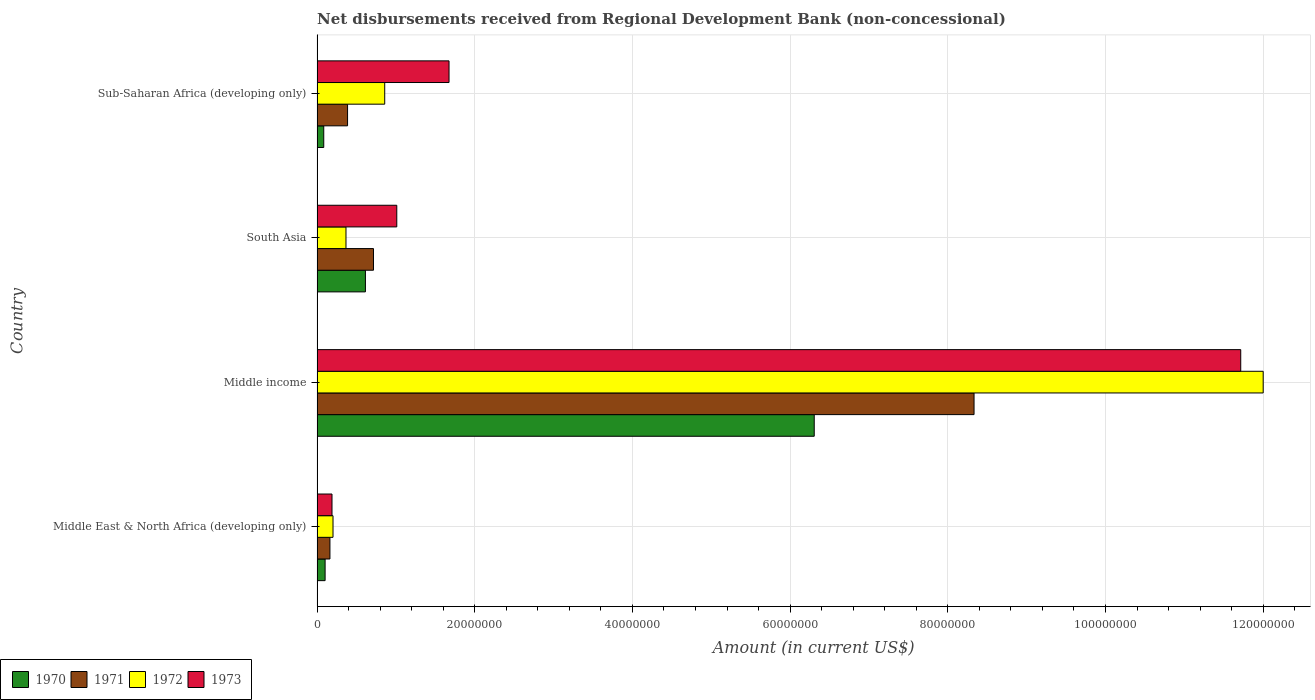How many different coloured bars are there?
Your answer should be very brief. 4. How many groups of bars are there?
Your response must be concise. 4. Are the number of bars on each tick of the Y-axis equal?
Give a very brief answer. Yes. How many bars are there on the 1st tick from the top?
Offer a very short reply. 4. In how many cases, is the number of bars for a given country not equal to the number of legend labels?
Provide a short and direct response. 0. What is the amount of disbursements received from Regional Development Bank in 1973 in Middle East & North Africa (developing only)?
Offer a very short reply. 1.90e+06. Across all countries, what is the maximum amount of disbursements received from Regional Development Bank in 1971?
Provide a succinct answer. 8.33e+07. Across all countries, what is the minimum amount of disbursements received from Regional Development Bank in 1972?
Your answer should be very brief. 2.02e+06. In which country was the amount of disbursements received from Regional Development Bank in 1970 maximum?
Provide a succinct answer. Middle income. In which country was the amount of disbursements received from Regional Development Bank in 1972 minimum?
Your response must be concise. Middle East & North Africa (developing only). What is the total amount of disbursements received from Regional Development Bank in 1972 in the graph?
Make the answer very short. 1.34e+08. What is the difference between the amount of disbursements received from Regional Development Bank in 1973 in Middle East & North Africa (developing only) and that in Sub-Saharan Africa (developing only)?
Keep it short and to the point. -1.48e+07. What is the difference between the amount of disbursements received from Regional Development Bank in 1972 in Sub-Saharan Africa (developing only) and the amount of disbursements received from Regional Development Bank in 1973 in Middle income?
Provide a short and direct response. -1.09e+08. What is the average amount of disbursements received from Regional Development Bank in 1973 per country?
Make the answer very short. 3.65e+07. What is the difference between the amount of disbursements received from Regional Development Bank in 1971 and amount of disbursements received from Regional Development Bank in 1972 in Middle East & North Africa (developing only)?
Your response must be concise. -3.89e+05. What is the ratio of the amount of disbursements received from Regional Development Bank in 1972 in Middle East & North Africa (developing only) to that in Sub-Saharan Africa (developing only)?
Provide a succinct answer. 0.24. What is the difference between the highest and the second highest amount of disbursements received from Regional Development Bank in 1972?
Give a very brief answer. 1.11e+08. What is the difference between the highest and the lowest amount of disbursements received from Regional Development Bank in 1970?
Your answer should be very brief. 6.22e+07. In how many countries, is the amount of disbursements received from Regional Development Bank in 1973 greater than the average amount of disbursements received from Regional Development Bank in 1973 taken over all countries?
Give a very brief answer. 1. Is it the case that in every country, the sum of the amount of disbursements received from Regional Development Bank in 1972 and amount of disbursements received from Regional Development Bank in 1970 is greater than the sum of amount of disbursements received from Regional Development Bank in 1971 and amount of disbursements received from Regional Development Bank in 1973?
Offer a terse response. No. What does the 4th bar from the top in Middle East & North Africa (developing only) represents?
Give a very brief answer. 1970. What does the 1st bar from the bottom in Sub-Saharan Africa (developing only) represents?
Provide a short and direct response. 1970. How many bars are there?
Offer a very short reply. 16. Are all the bars in the graph horizontal?
Your answer should be very brief. Yes. How many countries are there in the graph?
Your answer should be compact. 4. Are the values on the major ticks of X-axis written in scientific E-notation?
Offer a terse response. No. Does the graph contain any zero values?
Provide a succinct answer. No. Does the graph contain grids?
Your answer should be compact. Yes. Where does the legend appear in the graph?
Make the answer very short. Bottom left. How many legend labels are there?
Offer a very short reply. 4. How are the legend labels stacked?
Make the answer very short. Horizontal. What is the title of the graph?
Provide a succinct answer. Net disbursements received from Regional Development Bank (non-concessional). Does "1985" appear as one of the legend labels in the graph?
Make the answer very short. No. What is the label or title of the X-axis?
Provide a succinct answer. Amount (in current US$). What is the Amount (in current US$) in 1970 in Middle East & North Africa (developing only)?
Give a very brief answer. 1.02e+06. What is the Amount (in current US$) in 1971 in Middle East & North Africa (developing only)?
Your answer should be very brief. 1.64e+06. What is the Amount (in current US$) of 1972 in Middle East & North Africa (developing only)?
Your answer should be very brief. 2.02e+06. What is the Amount (in current US$) of 1973 in Middle East & North Africa (developing only)?
Provide a short and direct response. 1.90e+06. What is the Amount (in current US$) of 1970 in Middle income?
Your answer should be compact. 6.31e+07. What is the Amount (in current US$) in 1971 in Middle income?
Keep it short and to the point. 8.33e+07. What is the Amount (in current US$) of 1972 in Middle income?
Offer a terse response. 1.20e+08. What is the Amount (in current US$) of 1973 in Middle income?
Your answer should be very brief. 1.17e+08. What is the Amount (in current US$) in 1970 in South Asia?
Your answer should be very brief. 6.13e+06. What is the Amount (in current US$) in 1971 in South Asia?
Your answer should be very brief. 7.16e+06. What is the Amount (in current US$) in 1972 in South Asia?
Your answer should be very brief. 3.67e+06. What is the Amount (in current US$) of 1973 in South Asia?
Ensure brevity in your answer.  1.01e+07. What is the Amount (in current US$) in 1970 in Sub-Saharan Africa (developing only)?
Offer a very short reply. 8.50e+05. What is the Amount (in current US$) of 1971 in Sub-Saharan Africa (developing only)?
Your answer should be very brief. 3.87e+06. What is the Amount (in current US$) in 1972 in Sub-Saharan Africa (developing only)?
Ensure brevity in your answer.  8.58e+06. What is the Amount (in current US$) in 1973 in Sub-Saharan Africa (developing only)?
Offer a very short reply. 1.67e+07. Across all countries, what is the maximum Amount (in current US$) of 1970?
Provide a short and direct response. 6.31e+07. Across all countries, what is the maximum Amount (in current US$) in 1971?
Provide a succinct answer. 8.33e+07. Across all countries, what is the maximum Amount (in current US$) of 1972?
Ensure brevity in your answer.  1.20e+08. Across all countries, what is the maximum Amount (in current US$) of 1973?
Ensure brevity in your answer.  1.17e+08. Across all countries, what is the minimum Amount (in current US$) of 1970?
Your answer should be very brief. 8.50e+05. Across all countries, what is the minimum Amount (in current US$) of 1971?
Make the answer very short. 1.64e+06. Across all countries, what is the minimum Amount (in current US$) of 1972?
Offer a terse response. 2.02e+06. Across all countries, what is the minimum Amount (in current US$) in 1973?
Keep it short and to the point. 1.90e+06. What is the total Amount (in current US$) of 1970 in the graph?
Offer a terse response. 7.11e+07. What is the total Amount (in current US$) of 1971 in the graph?
Offer a very short reply. 9.60e+07. What is the total Amount (in current US$) in 1972 in the graph?
Offer a very short reply. 1.34e+08. What is the total Amount (in current US$) in 1973 in the graph?
Provide a succinct answer. 1.46e+08. What is the difference between the Amount (in current US$) of 1970 in Middle East & North Africa (developing only) and that in Middle income?
Your answer should be compact. -6.20e+07. What is the difference between the Amount (in current US$) in 1971 in Middle East & North Africa (developing only) and that in Middle income?
Keep it short and to the point. -8.17e+07. What is the difference between the Amount (in current US$) of 1972 in Middle East & North Africa (developing only) and that in Middle income?
Offer a very short reply. -1.18e+08. What is the difference between the Amount (in current US$) in 1973 in Middle East & North Africa (developing only) and that in Middle income?
Your response must be concise. -1.15e+08. What is the difference between the Amount (in current US$) of 1970 in Middle East & North Africa (developing only) and that in South Asia?
Your response must be concise. -5.11e+06. What is the difference between the Amount (in current US$) in 1971 in Middle East & North Africa (developing only) and that in South Asia?
Your answer should be very brief. -5.52e+06. What is the difference between the Amount (in current US$) of 1972 in Middle East & North Africa (developing only) and that in South Asia?
Ensure brevity in your answer.  -1.64e+06. What is the difference between the Amount (in current US$) of 1973 in Middle East & North Africa (developing only) and that in South Asia?
Offer a terse response. -8.22e+06. What is the difference between the Amount (in current US$) in 1970 in Middle East & North Africa (developing only) and that in Sub-Saharan Africa (developing only)?
Ensure brevity in your answer.  1.71e+05. What is the difference between the Amount (in current US$) in 1971 in Middle East & North Africa (developing only) and that in Sub-Saharan Africa (developing only)?
Ensure brevity in your answer.  -2.23e+06. What is the difference between the Amount (in current US$) of 1972 in Middle East & North Africa (developing only) and that in Sub-Saharan Africa (developing only)?
Keep it short and to the point. -6.56e+06. What is the difference between the Amount (in current US$) in 1973 in Middle East & North Africa (developing only) and that in Sub-Saharan Africa (developing only)?
Offer a terse response. -1.48e+07. What is the difference between the Amount (in current US$) in 1970 in Middle income and that in South Asia?
Provide a succinct answer. 5.69e+07. What is the difference between the Amount (in current US$) of 1971 in Middle income and that in South Asia?
Your answer should be compact. 7.62e+07. What is the difference between the Amount (in current US$) of 1972 in Middle income and that in South Asia?
Provide a succinct answer. 1.16e+08. What is the difference between the Amount (in current US$) of 1973 in Middle income and that in South Asia?
Your response must be concise. 1.07e+08. What is the difference between the Amount (in current US$) in 1970 in Middle income and that in Sub-Saharan Africa (developing only)?
Offer a very short reply. 6.22e+07. What is the difference between the Amount (in current US$) in 1971 in Middle income and that in Sub-Saharan Africa (developing only)?
Keep it short and to the point. 7.95e+07. What is the difference between the Amount (in current US$) of 1972 in Middle income and that in Sub-Saharan Africa (developing only)?
Offer a terse response. 1.11e+08. What is the difference between the Amount (in current US$) in 1973 in Middle income and that in Sub-Saharan Africa (developing only)?
Ensure brevity in your answer.  1.00e+08. What is the difference between the Amount (in current US$) of 1970 in South Asia and that in Sub-Saharan Africa (developing only)?
Keep it short and to the point. 5.28e+06. What is the difference between the Amount (in current US$) of 1971 in South Asia and that in Sub-Saharan Africa (developing only)?
Provide a short and direct response. 3.29e+06. What is the difference between the Amount (in current US$) of 1972 in South Asia and that in Sub-Saharan Africa (developing only)?
Your response must be concise. -4.91e+06. What is the difference between the Amount (in current US$) of 1973 in South Asia and that in Sub-Saharan Africa (developing only)?
Offer a terse response. -6.63e+06. What is the difference between the Amount (in current US$) of 1970 in Middle East & North Africa (developing only) and the Amount (in current US$) of 1971 in Middle income?
Your answer should be compact. -8.23e+07. What is the difference between the Amount (in current US$) in 1970 in Middle East & North Africa (developing only) and the Amount (in current US$) in 1972 in Middle income?
Keep it short and to the point. -1.19e+08. What is the difference between the Amount (in current US$) of 1970 in Middle East & North Africa (developing only) and the Amount (in current US$) of 1973 in Middle income?
Provide a short and direct response. -1.16e+08. What is the difference between the Amount (in current US$) of 1971 in Middle East & North Africa (developing only) and the Amount (in current US$) of 1972 in Middle income?
Give a very brief answer. -1.18e+08. What is the difference between the Amount (in current US$) in 1971 in Middle East & North Africa (developing only) and the Amount (in current US$) in 1973 in Middle income?
Give a very brief answer. -1.16e+08. What is the difference between the Amount (in current US$) in 1972 in Middle East & North Africa (developing only) and the Amount (in current US$) in 1973 in Middle income?
Your response must be concise. -1.15e+08. What is the difference between the Amount (in current US$) in 1970 in Middle East & North Africa (developing only) and the Amount (in current US$) in 1971 in South Asia?
Give a very brief answer. -6.14e+06. What is the difference between the Amount (in current US$) in 1970 in Middle East & North Africa (developing only) and the Amount (in current US$) in 1972 in South Asia?
Provide a succinct answer. -2.65e+06. What is the difference between the Amount (in current US$) in 1970 in Middle East & North Africa (developing only) and the Amount (in current US$) in 1973 in South Asia?
Provide a succinct answer. -9.09e+06. What is the difference between the Amount (in current US$) of 1971 in Middle East & North Africa (developing only) and the Amount (in current US$) of 1972 in South Asia?
Keep it short and to the point. -2.03e+06. What is the difference between the Amount (in current US$) of 1971 in Middle East & North Africa (developing only) and the Amount (in current US$) of 1973 in South Asia?
Keep it short and to the point. -8.48e+06. What is the difference between the Amount (in current US$) in 1972 in Middle East & North Africa (developing only) and the Amount (in current US$) in 1973 in South Asia?
Provide a short and direct response. -8.09e+06. What is the difference between the Amount (in current US$) in 1970 in Middle East & North Africa (developing only) and the Amount (in current US$) in 1971 in Sub-Saharan Africa (developing only)?
Provide a succinct answer. -2.85e+06. What is the difference between the Amount (in current US$) of 1970 in Middle East & North Africa (developing only) and the Amount (in current US$) of 1972 in Sub-Saharan Africa (developing only)?
Keep it short and to the point. -7.56e+06. What is the difference between the Amount (in current US$) in 1970 in Middle East & North Africa (developing only) and the Amount (in current US$) in 1973 in Sub-Saharan Africa (developing only)?
Offer a very short reply. -1.57e+07. What is the difference between the Amount (in current US$) in 1971 in Middle East & North Africa (developing only) and the Amount (in current US$) in 1972 in Sub-Saharan Africa (developing only)?
Offer a terse response. -6.95e+06. What is the difference between the Amount (in current US$) of 1971 in Middle East & North Africa (developing only) and the Amount (in current US$) of 1973 in Sub-Saharan Africa (developing only)?
Keep it short and to the point. -1.51e+07. What is the difference between the Amount (in current US$) of 1972 in Middle East & North Africa (developing only) and the Amount (in current US$) of 1973 in Sub-Saharan Africa (developing only)?
Provide a short and direct response. -1.47e+07. What is the difference between the Amount (in current US$) of 1970 in Middle income and the Amount (in current US$) of 1971 in South Asia?
Ensure brevity in your answer.  5.59e+07. What is the difference between the Amount (in current US$) of 1970 in Middle income and the Amount (in current US$) of 1972 in South Asia?
Provide a short and direct response. 5.94e+07. What is the difference between the Amount (in current US$) of 1970 in Middle income and the Amount (in current US$) of 1973 in South Asia?
Offer a very short reply. 5.29e+07. What is the difference between the Amount (in current US$) of 1971 in Middle income and the Amount (in current US$) of 1972 in South Asia?
Offer a very short reply. 7.97e+07. What is the difference between the Amount (in current US$) in 1971 in Middle income and the Amount (in current US$) in 1973 in South Asia?
Your response must be concise. 7.32e+07. What is the difference between the Amount (in current US$) of 1972 in Middle income and the Amount (in current US$) of 1973 in South Asia?
Make the answer very short. 1.10e+08. What is the difference between the Amount (in current US$) of 1970 in Middle income and the Amount (in current US$) of 1971 in Sub-Saharan Africa (developing only)?
Provide a succinct answer. 5.92e+07. What is the difference between the Amount (in current US$) in 1970 in Middle income and the Amount (in current US$) in 1972 in Sub-Saharan Africa (developing only)?
Offer a terse response. 5.45e+07. What is the difference between the Amount (in current US$) in 1970 in Middle income and the Amount (in current US$) in 1973 in Sub-Saharan Africa (developing only)?
Give a very brief answer. 4.63e+07. What is the difference between the Amount (in current US$) in 1971 in Middle income and the Amount (in current US$) in 1972 in Sub-Saharan Africa (developing only)?
Your answer should be very brief. 7.47e+07. What is the difference between the Amount (in current US$) in 1971 in Middle income and the Amount (in current US$) in 1973 in Sub-Saharan Africa (developing only)?
Keep it short and to the point. 6.66e+07. What is the difference between the Amount (in current US$) in 1972 in Middle income and the Amount (in current US$) in 1973 in Sub-Saharan Africa (developing only)?
Give a very brief answer. 1.03e+08. What is the difference between the Amount (in current US$) in 1970 in South Asia and the Amount (in current US$) in 1971 in Sub-Saharan Africa (developing only)?
Your answer should be very brief. 2.26e+06. What is the difference between the Amount (in current US$) of 1970 in South Asia and the Amount (in current US$) of 1972 in Sub-Saharan Africa (developing only)?
Offer a very short reply. -2.45e+06. What is the difference between the Amount (in current US$) in 1970 in South Asia and the Amount (in current US$) in 1973 in Sub-Saharan Africa (developing only)?
Your answer should be very brief. -1.06e+07. What is the difference between the Amount (in current US$) in 1971 in South Asia and the Amount (in current US$) in 1972 in Sub-Saharan Africa (developing only)?
Make the answer very short. -1.42e+06. What is the difference between the Amount (in current US$) of 1971 in South Asia and the Amount (in current US$) of 1973 in Sub-Saharan Africa (developing only)?
Provide a short and direct response. -9.58e+06. What is the difference between the Amount (in current US$) of 1972 in South Asia and the Amount (in current US$) of 1973 in Sub-Saharan Africa (developing only)?
Offer a terse response. -1.31e+07. What is the average Amount (in current US$) of 1970 per country?
Your answer should be very brief. 1.78e+07. What is the average Amount (in current US$) of 1971 per country?
Provide a short and direct response. 2.40e+07. What is the average Amount (in current US$) in 1972 per country?
Keep it short and to the point. 3.36e+07. What is the average Amount (in current US$) in 1973 per country?
Offer a terse response. 3.65e+07. What is the difference between the Amount (in current US$) of 1970 and Amount (in current US$) of 1971 in Middle East & North Africa (developing only)?
Provide a short and direct response. -6.14e+05. What is the difference between the Amount (in current US$) of 1970 and Amount (in current US$) of 1972 in Middle East & North Africa (developing only)?
Make the answer very short. -1.00e+06. What is the difference between the Amount (in current US$) in 1970 and Amount (in current US$) in 1973 in Middle East & North Africa (developing only)?
Give a very brief answer. -8.75e+05. What is the difference between the Amount (in current US$) in 1971 and Amount (in current US$) in 1972 in Middle East & North Africa (developing only)?
Ensure brevity in your answer.  -3.89e+05. What is the difference between the Amount (in current US$) in 1971 and Amount (in current US$) in 1973 in Middle East & North Africa (developing only)?
Your answer should be compact. -2.61e+05. What is the difference between the Amount (in current US$) in 1972 and Amount (in current US$) in 1973 in Middle East & North Africa (developing only)?
Provide a succinct answer. 1.28e+05. What is the difference between the Amount (in current US$) of 1970 and Amount (in current US$) of 1971 in Middle income?
Your answer should be very brief. -2.03e+07. What is the difference between the Amount (in current US$) of 1970 and Amount (in current US$) of 1972 in Middle income?
Provide a succinct answer. -5.69e+07. What is the difference between the Amount (in current US$) of 1970 and Amount (in current US$) of 1973 in Middle income?
Provide a short and direct response. -5.41e+07. What is the difference between the Amount (in current US$) of 1971 and Amount (in current US$) of 1972 in Middle income?
Give a very brief answer. -3.67e+07. What is the difference between the Amount (in current US$) in 1971 and Amount (in current US$) in 1973 in Middle income?
Give a very brief answer. -3.38e+07. What is the difference between the Amount (in current US$) in 1972 and Amount (in current US$) in 1973 in Middle income?
Provide a short and direct response. 2.85e+06. What is the difference between the Amount (in current US$) in 1970 and Amount (in current US$) in 1971 in South Asia?
Your answer should be compact. -1.02e+06. What is the difference between the Amount (in current US$) of 1970 and Amount (in current US$) of 1972 in South Asia?
Provide a succinct answer. 2.46e+06. What is the difference between the Amount (in current US$) in 1970 and Amount (in current US$) in 1973 in South Asia?
Make the answer very short. -3.98e+06. What is the difference between the Amount (in current US$) of 1971 and Amount (in current US$) of 1972 in South Asia?
Ensure brevity in your answer.  3.49e+06. What is the difference between the Amount (in current US$) of 1971 and Amount (in current US$) of 1973 in South Asia?
Your answer should be compact. -2.95e+06. What is the difference between the Amount (in current US$) of 1972 and Amount (in current US$) of 1973 in South Asia?
Offer a terse response. -6.44e+06. What is the difference between the Amount (in current US$) of 1970 and Amount (in current US$) of 1971 in Sub-Saharan Africa (developing only)?
Make the answer very short. -3.02e+06. What is the difference between the Amount (in current US$) of 1970 and Amount (in current US$) of 1972 in Sub-Saharan Africa (developing only)?
Your response must be concise. -7.73e+06. What is the difference between the Amount (in current US$) of 1970 and Amount (in current US$) of 1973 in Sub-Saharan Africa (developing only)?
Make the answer very short. -1.59e+07. What is the difference between the Amount (in current US$) in 1971 and Amount (in current US$) in 1972 in Sub-Saharan Africa (developing only)?
Your answer should be compact. -4.71e+06. What is the difference between the Amount (in current US$) in 1971 and Amount (in current US$) in 1973 in Sub-Saharan Africa (developing only)?
Provide a succinct answer. -1.29e+07. What is the difference between the Amount (in current US$) in 1972 and Amount (in current US$) in 1973 in Sub-Saharan Africa (developing only)?
Provide a succinct answer. -8.16e+06. What is the ratio of the Amount (in current US$) in 1970 in Middle East & North Africa (developing only) to that in Middle income?
Offer a very short reply. 0.02. What is the ratio of the Amount (in current US$) in 1971 in Middle East & North Africa (developing only) to that in Middle income?
Your answer should be very brief. 0.02. What is the ratio of the Amount (in current US$) in 1972 in Middle East & North Africa (developing only) to that in Middle income?
Give a very brief answer. 0.02. What is the ratio of the Amount (in current US$) of 1973 in Middle East & North Africa (developing only) to that in Middle income?
Provide a short and direct response. 0.02. What is the ratio of the Amount (in current US$) in 1970 in Middle East & North Africa (developing only) to that in South Asia?
Your answer should be very brief. 0.17. What is the ratio of the Amount (in current US$) of 1971 in Middle East & North Africa (developing only) to that in South Asia?
Ensure brevity in your answer.  0.23. What is the ratio of the Amount (in current US$) in 1972 in Middle East & North Africa (developing only) to that in South Asia?
Make the answer very short. 0.55. What is the ratio of the Amount (in current US$) in 1973 in Middle East & North Africa (developing only) to that in South Asia?
Offer a terse response. 0.19. What is the ratio of the Amount (in current US$) in 1970 in Middle East & North Africa (developing only) to that in Sub-Saharan Africa (developing only)?
Ensure brevity in your answer.  1.2. What is the ratio of the Amount (in current US$) in 1971 in Middle East & North Africa (developing only) to that in Sub-Saharan Africa (developing only)?
Keep it short and to the point. 0.42. What is the ratio of the Amount (in current US$) of 1972 in Middle East & North Africa (developing only) to that in Sub-Saharan Africa (developing only)?
Keep it short and to the point. 0.24. What is the ratio of the Amount (in current US$) in 1973 in Middle East & North Africa (developing only) to that in Sub-Saharan Africa (developing only)?
Offer a very short reply. 0.11. What is the ratio of the Amount (in current US$) in 1970 in Middle income to that in South Asia?
Give a very brief answer. 10.28. What is the ratio of the Amount (in current US$) of 1971 in Middle income to that in South Asia?
Provide a succinct answer. 11.64. What is the ratio of the Amount (in current US$) in 1972 in Middle income to that in South Asia?
Provide a succinct answer. 32.71. What is the ratio of the Amount (in current US$) in 1973 in Middle income to that in South Asia?
Offer a terse response. 11.58. What is the ratio of the Amount (in current US$) in 1970 in Middle income to that in Sub-Saharan Africa (developing only)?
Offer a terse response. 74.18. What is the ratio of the Amount (in current US$) in 1971 in Middle income to that in Sub-Saharan Africa (developing only)?
Ensure brevity in your answer.  21.54. What is the ratio of the Amount (in current US$) of 1972 in Middle income to that in Sub-Saharan Africa (developing only)?
Give a very brief answer. 13.98. What is the ratio of the Amount (in current US$) of 1973 in Middle income to that in Sub-Saharan Africa (developing only)?
Ensure brevity in your answer.  7. What is the ratio of the Amount (in current US$) in 1970 in South Asia to that in Sub-Saharan Africa (developing only)?
Offer a terse response. 7.22. What is the ratio of the Amount (in current US$) of 1971 in South Asia to that in Sub-Saharan Africa (developing only)?
Keep it short and to the point. 1.85. What is the ratio of the Amount (in current US$) in 1972 in South Asia to that in Sub-Saharan Africa (developing only)?
Your answer should be compact. 0.43. What is the ratio of the Amount (in current US$) in 1973 in South Asia to that in Sub-Saharan Africa (developing only)?
Your response must be concise. 0.6. What is the difference between the highest and the second highest Amount (in current US$) in 1970?
Keep it short and to the point. 5.69e+07. What is the difference between the highest and the second highest Amount (in current US$) in 1971?
Offer a very short reply. 7.62e+07. What is the difference between the highest and the second highest Amount (in current US$) in 1972?
Provide a short and direct response. 1.11e+08. What is the difference between the highest and the second highest Amount (in current US$) in 1973?
Offer a very short reply. 1.00e+08. What is the difference between the highest and the lowest Amount (in current US$) in 1970?
Ensure brevity in your answer.  6.22e+07. What is the difference between the highest and the lowest Amount (in current US$) in 1971?
Offer a very short reply. 8.17e+07. What is the difference between the highest and the lowest Amount (in current US$) in 1972?
Make the answer very short. 1.18e+08. What is the difference between the highest and the lowest Amount (in current US$) of 1973?
Provide a succinct answer. 1.15e+08. 